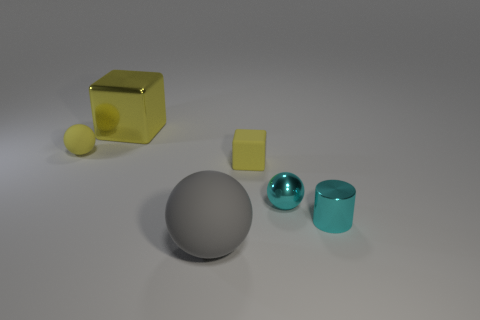There is a tiny thing that is the same color as the metal sphere; what is its shape?
Give a very brief answer. Cylinder. How many yellow metallic things have the same size as the cyan metallic sphere?
Your answer should be compact. 0. There is a matte thing to the left of the gray rubber sphere; is its shape the same as the matte object in front of the small cube?
Make the answer very short. Yes. What material is the yellow cube that is behind the matte sphere behind the object in front of the small cyan cylinder?
Provide a succinct answer. Metal. What shape is the metallic thing that is the same size as the shiny ball?
Provide a succinct answer. Cylinder. Is there a shiny ball of the same color as the large shiny thing?
Give a very brief answer. No. What is the size of the gray thing?
Make the answer very short. Large. Is the gray sphere made of the same material as the small yellow sphere?
Provide a succinct answer. Yes. What number of cyan metallic things are in front of the thing that is behind the thing left of the yellow metallic block?
Offer a very short reply. 2. The cyan shiny object on the right side of the cyan metallic sphere has what shape?
Offer a terse response. Cylinder. 